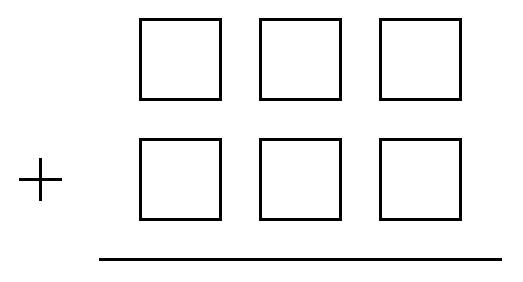Explain the significance of the digit's placement within these boxes. Digit placement within each box directly affects the value of the resultant number. Placing a higher digit in the hundreds place significantly increases the number's value compared to placing it in the tens or units place. The sum and overall value of any arithmetic operations distort significantly based on these placements. For instance, the digit 5 contributes more to the total sum when placed in the hundreds place as 500, versus 5 when placed in the units place. 